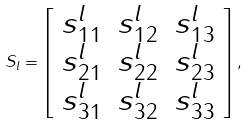<formula> <loc_0><loc_0><loc_500><loc_500>S _ { l } = \left [ \begin{array} { c c c } s ^ { l } _ { 1 1 } & s ^ { l } _ { 1 2 } & s ^ { l } _ { 1 3 } \\ s ^ { l } _ { 2 1 } & s ^ { l } _ { 2 2 } & s ^ { l } _ { 2 3 } \\ s ^ { l } _ { 3 1 } & s ^ { l } _ { 3 2 } & s ^ { l } _ { 3 3 } \end{array} \right ] ,</formula> 